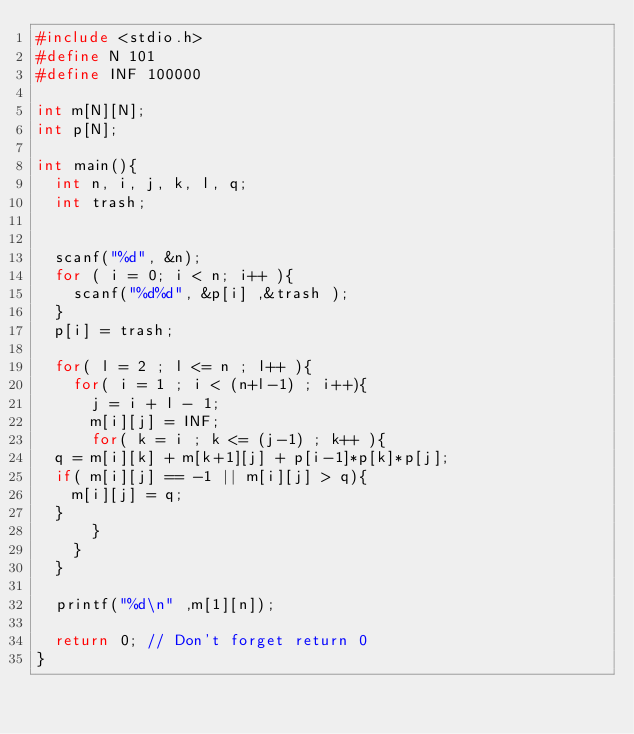<code> <loc_0><loc_0><loc_500><loc_500><_C_>#include <stdio.h>
#define N 101
#define INF 100000

int m[N][N];
int p[N];

int main(){
  int n, i, j, k, l, q;
  int trash;


  scanf("%d", &n);
  for ( i = 0; i < n; i++ ){
    scanf("%d%d", &p[i] ,&trash );
  }
  p[i] = trash;

  for( l = 2 ; l <= n ; l++ ){
    for( i = 1 ; i < (n+l-1) ; i++){
      j = i + l - 1;
      m[i][j] = INF;
      for( k = i ; k <= (j-1) ; k++ ){
	q = m[i][k] + m[k+1][j] + p[i-1]*p[k]*p[j];
	if( m[i][j] == -1 || m[i][j] > q){
	  m[i][j] = q;
	}
      }
    }
  }

  printf("%d\n" ,m[1][n]);

  return 0; // Don't forget return 0
}</code> 